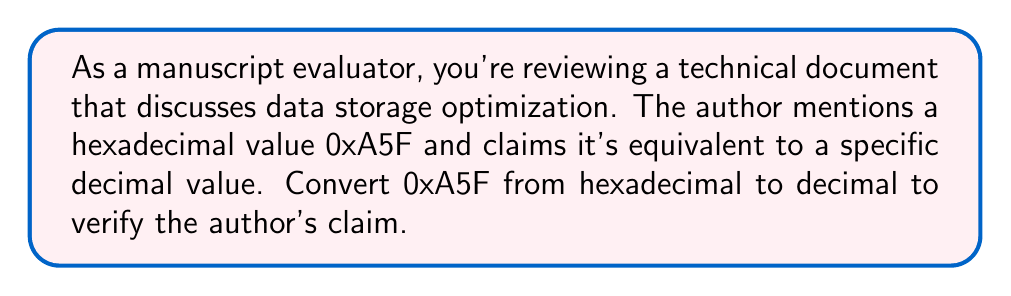Help me with this question. To convert a hexadecimal number to decimal, we need to multiply each digit by the appropriate power of 16 and sum the results. Let's break it down step-by-step:

1) In hexadecimal, each digit represents a power of 16. From right to left, the powers are $16^0$, $16^1$, $16^2$, and so on.

2) The hexadecimal number 0xA5F can be expanded as:

   $$A \times 16^2 + 5 \times 16^1 + F \times 16^0$$

3) In hexadecimal, A represents 10 and F represents 15. So we can rewrite this as:

   $$10 \times 16^2 + 5 \times 16^1 + 15 \times 16^0$$

4) Now let's calculate each term:
   - $10 \times 16^2 = 10 \times 256 = 2560$
   - $5 \times 16^1 = 5 \times 16 = 80$
   - $15 \times 16^0 = 15 \times 1 = 15$

5) Sum up all the terms:

   $$2560 + 80 + 15 = 2655$$

Therefore, the hexadecimal number 0xA5F is equivalent to the decimal number 2655.
Answer: 2655 